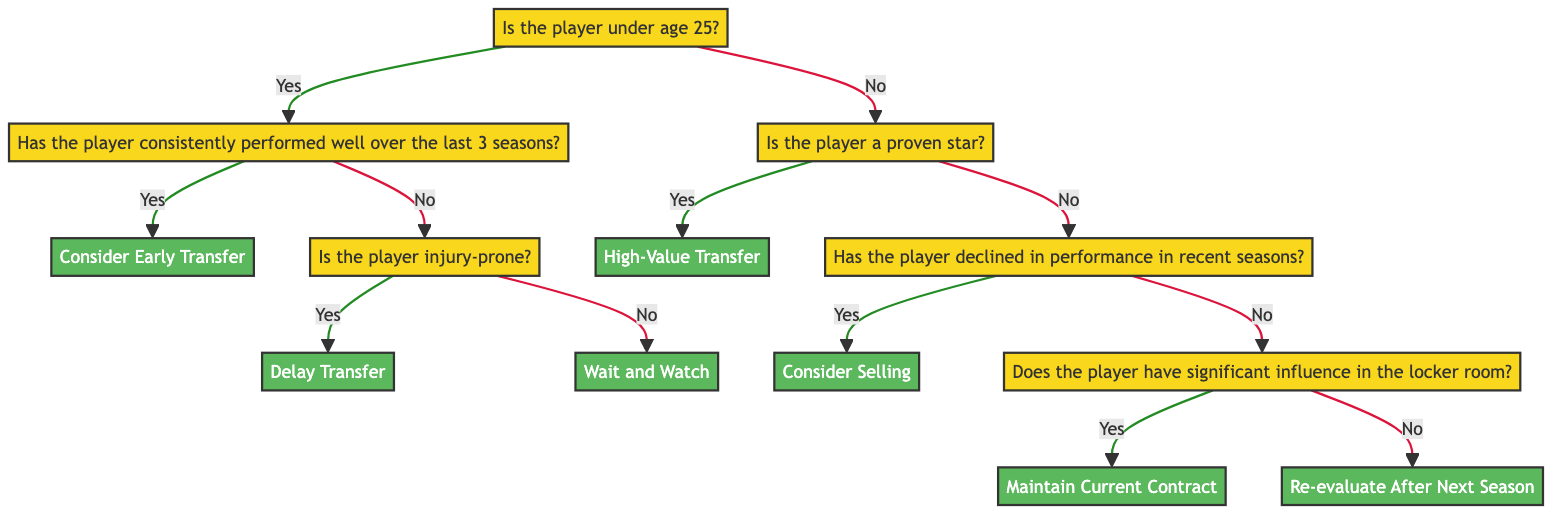Is the player under age 25? The starting question of the decision tree checks the age of the player. This node leads the flow of the decision tree based on whether the answer is "Yes" or "No". Thus, it is the first and key question that determines the subsequent path in the tree.
Answer: Yes How many decisions are there in the tree? By counting the distinct decision nodes (those that provide a recommendation), we can find the total number of decisions. The decisions are: Consider Early Transfer, Delay Transfer, Wait and Watch, High-Value Transfer, Consider Selling, Maintain Current Contract, Re-evaluate After Next Season. Counting these gives us a total of 7 decision nodes.
Answer: 7 What happens if the player has consistently performed well but is injury-prone? If a player under age 25 has performed well but is also identified as injury-prone, the decision-making path leads to the node "Delay Transfer". This outcome suggests caution due to the potential risks associated with injuries.
Answer: Delay Transfer What reason is given for delaying the transfer of an injury-prone player? The reasoning provided states that "Injury-prone young players should prove their physical resilience before being considered for a high-value contract." This highlights the concern of their ability to perform consistently.
Answer: Injury-prone players need to prove physical resilience Does the tree suggest selling a player who has declined in performance? Yes, if an older player has declined in performance in recent seasons, the decision node indicates "Consider Selling". This implies the potential for a good transfer fee while recognizing associated long-term risks.
Answer: Consider Selling What is the recommended action for a player who is a proven star? The decision tree states that a proven star, such as Lionel Messi or Cristiano Ronaldo, leads to the action "High-Value Transfer". These players are recognized for their immediate value and experience, which justifies a high contract.
Answer: High-Value Transfer If an older player has significant locker room influence but not star status, what should the team do? The decision tree directs that older players without star status but with significant influence should "Maintain Current Contract". This reflects the value of their leadership and influence beyond just performance.
Answer: Maintain Current Contract What do we know about the recommendation for a young player who hasn't performed consistently? The flow indicates that if a young player has not performed consistently, the recommendation is "Wait and Watch". This approach allows time for evaluation of the player's development or decline.
Answer: Wait and Watch What is the path if the player is older but has not declined in performance? The pathway indicates that if the player is older and has not declined in performance, the next decision is based on their influence in the locker room, leading either to "Maintain Current Contract" or "Re-evaluate After Next Season". This shows the importance of context around their performance and leadership roles.
Answer: Maintain Current Contract or Re-evaluate After Next Season 